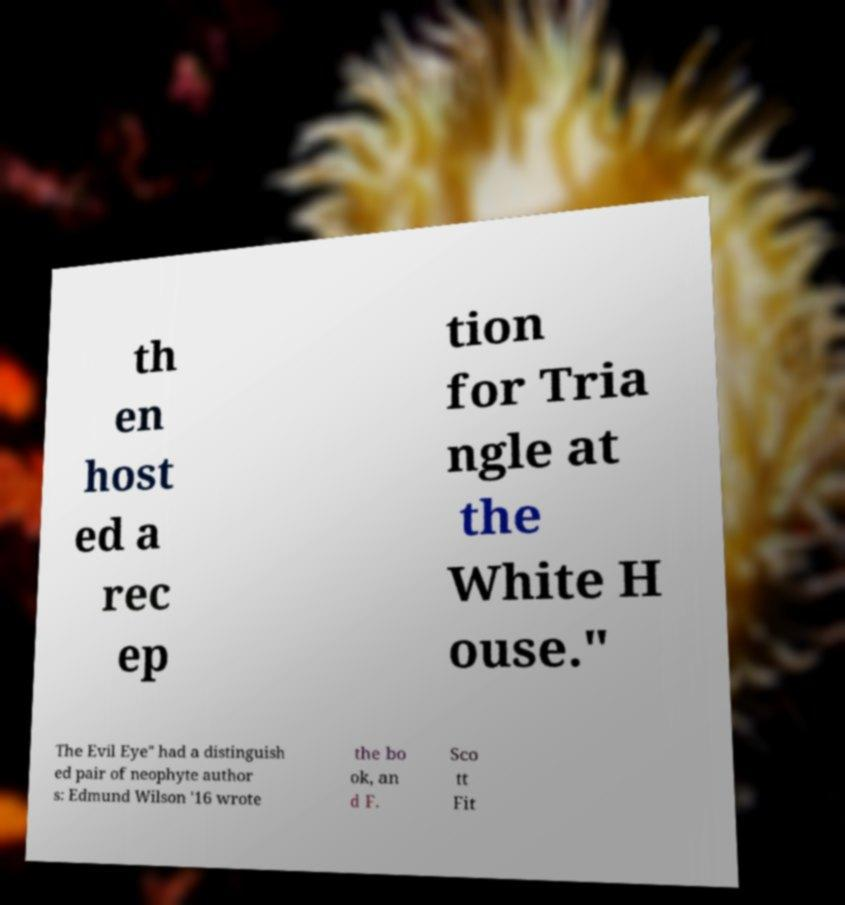For documentation purposes, I need the text within this image transcribed. Could you provide that? th en host ed a rec ep tion for Tria ngle at the White H ouse." The Evil Eye" had a distinguish ed pair of neophyte author s: Edmund Wilson '16 wrote the bo ok, an d F. Sco tt Fit 